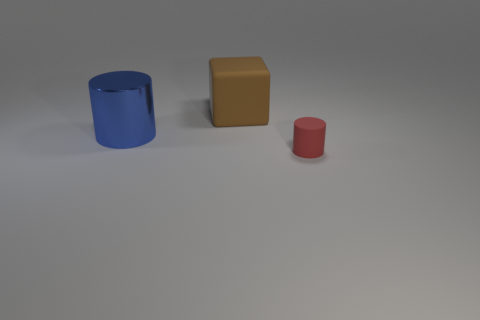Are there any other things that are the same size as the matte cylinder?
Provide a succinct answer. No. Are there any other things that are made of the same material as the large cylinder?
Give a very brief answer. No. Are there any large blue shiny cylinders right of the big blue metallic cylinder?
Your response must be concise. No. Are there any other things that are the same shape as the small rubber thing?
Make the answer very short. Yes. Do the brown rubber object and the large blue metal thing have the same shape?
Give a very brief answer. No. Are there an equal number of cylinders that are on the left side of the red rubber cylinder and blue metallic things that are on the left side of the big blue metal cylinder?
Your answer should be very brief. No. What number of other objects are the same material as the large blue object?
Offer a very short reply. 0. How many big things are either metal things or purple spheres?
Offer a very short reply. 1. Are there the same number of big blocks to the left of the blue cylinder and brown things?
Your answer should be very brief. No. Are there any large cylinders on the left side of the matte object left of the matte cylinder?
Keep it short and to the point. Yes. 